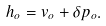Convert formula to latex. <formula><loc_0><loc_0><loc_500><loc_500>h _ { o } = v _ { o } + \delta p _ { o } .</formula> 